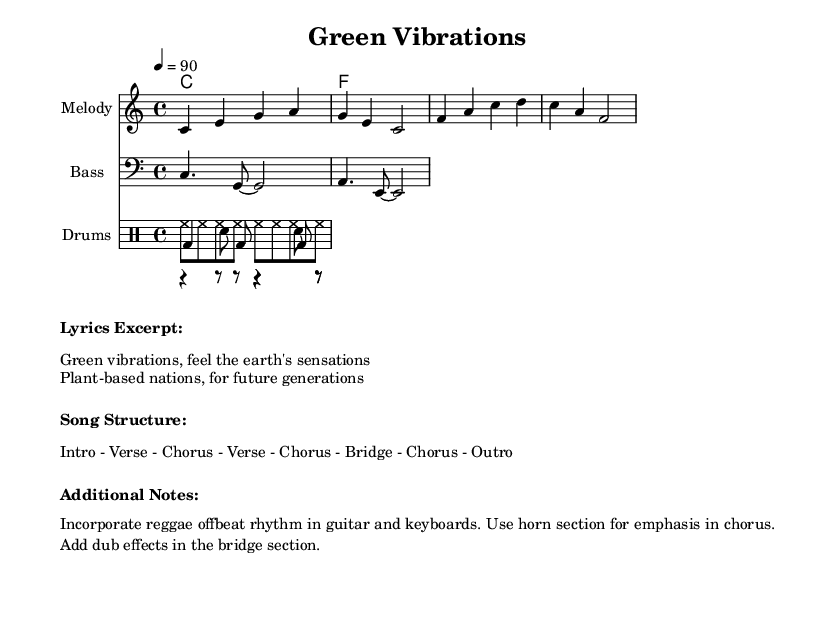What is the key signature of this music? The key signature is C major, which has no sharps or flats.
Answer: C major What is the time signature of this music? The time signature is indicated in the score and shows that there are four beats per measure.
Answer: 4/4 What is the tempo marking of this piece? The tempo marking is found at the beginning and indicates the speed at which the piece should be played, specified as 90 beats per minute.
Answer: 90 What is the structure of the song? The structure is prominently displayed in the markup section, which details the order of the sections through the entirety of the song.
Answer: Intro - Verse - Chorus - Verse - Chorus - Bridge - Chorus - Outro What elements are included in the drum section? By looking at the drum staff, we can identify three different types of drum parts: kick, snare, and hi-hat.
Answer: Kick, snare, hi-hat How does the bass line relate to the melody? The bass line provides a harmonic foundation under the melody, usually played in a rhythmic pattern to complement the melody's notes.
Answer: Complementary foundation What unique musical features are suggested in the additional notes? The additional notes indicate specific stylistic elements, such as incorporating reggae offbeat rhythms and dub effects, which are characteristic of reggae fusion.
Answer: Offbeat rhythms, dub effects 